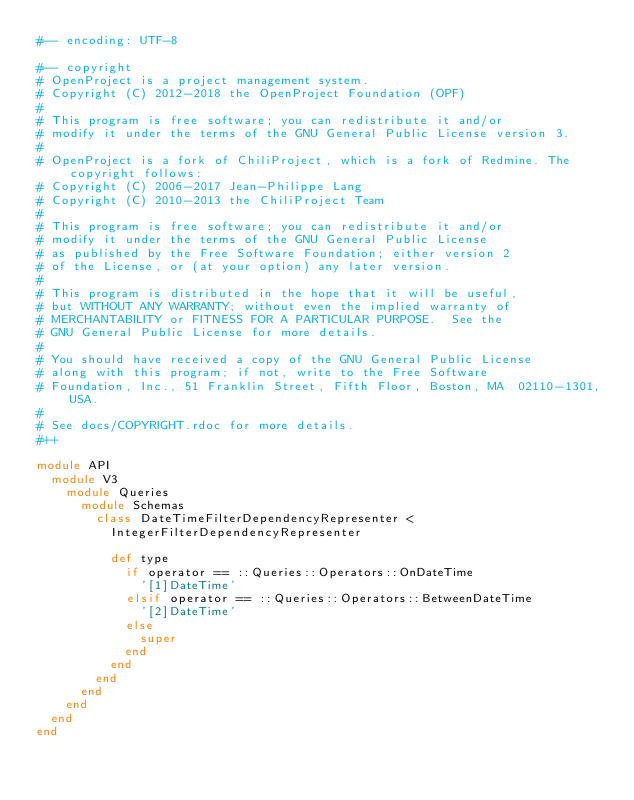Convert code to text. <code><loc_0><loc_0><loc_500><loc_500><_Ruby_>#-- encoding: UTF-8

#-- copyright
# OpenProject is a project management system.
# Copyright (C) 2012-2018 the OpenProject Foundation (OPF)
#
# This program is free software; you can redistribute it and/or
# modify it under the terms of the GNU General Public License version 3.
#
# OpenProject is a fork of ChiliProject, which is a fork of Redmine. The copyright follows:
# Copyright (C) 2006-2017 Jean-Philippe Lang
# Copyright (C) 2010-2013 the ChiliProject Team
#
# This program is free software; you can redistribute it and/or
# modify it under the terms of the GNU General Public License
# as published by the Free Software Foundation; either version 2
# of the License, or (at your option) any later version.
#
# This program is distributed in the hope that it will be useful,
# but WITHOUT ANY WARRANTY; without even the implied warranty of
# MERCHANTABILITY or FITNESS FOR A PARTICULAR PURPOSE.  See the
# GNU General Public License for more details.
#
# You should have received a copy of the GNU General Public License
# along with this program; if not, write to the Free Software
# Foundation, Inc., 51 Franklin Street, Fifth Floor, Boston, MA  02110-1301, USA.
#
# See docs/COPYRIGHT.rdoc for more details.
#++

module API
  module V3
    module Queries
      module Schemas
        class DateTimeFilterDependencyRepresenter <
          IntegerFilterDependencyRepresenter

          def type
            if operator == ::Queries::Operators::OnDateTime
              '[1]DateTime'
            elsif operator == ::Queries::Operators::BetweenDateTime
              '[2]DateTime'
            else
              super
            end
          end
        end
      end
    end
  end
end
</code> 